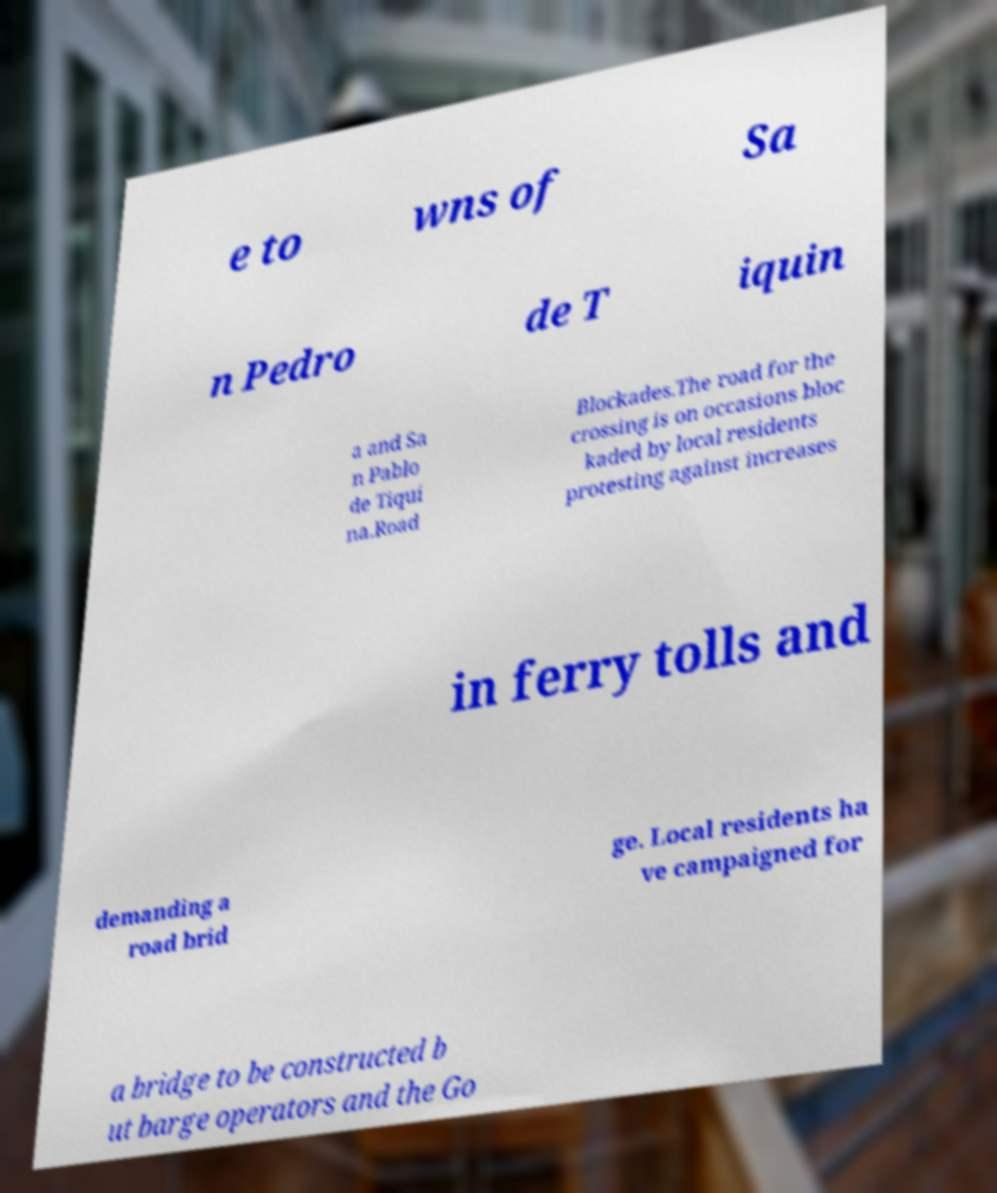I need the written content from this picture converted into text. Can you do that? e to wns of Sa n Pedro de T iquin a and Sa n Pablo de Tiqui na.Road Blockades.The road for the crossing is on occasions bloc kaded by local residents protesting against increases in ferry tolls and demanding a road brid ge. Local residents ha ve campaigned for a bridge to be constructed b ut barge operators and the Go 